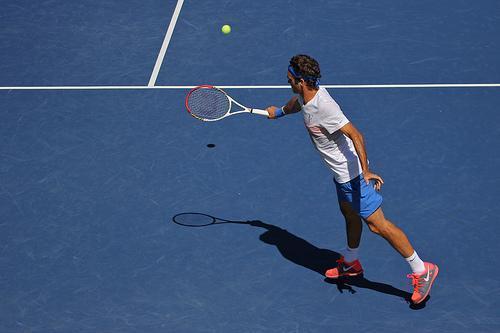How many white lines are on the court?
Give a very brief answer. 2. 